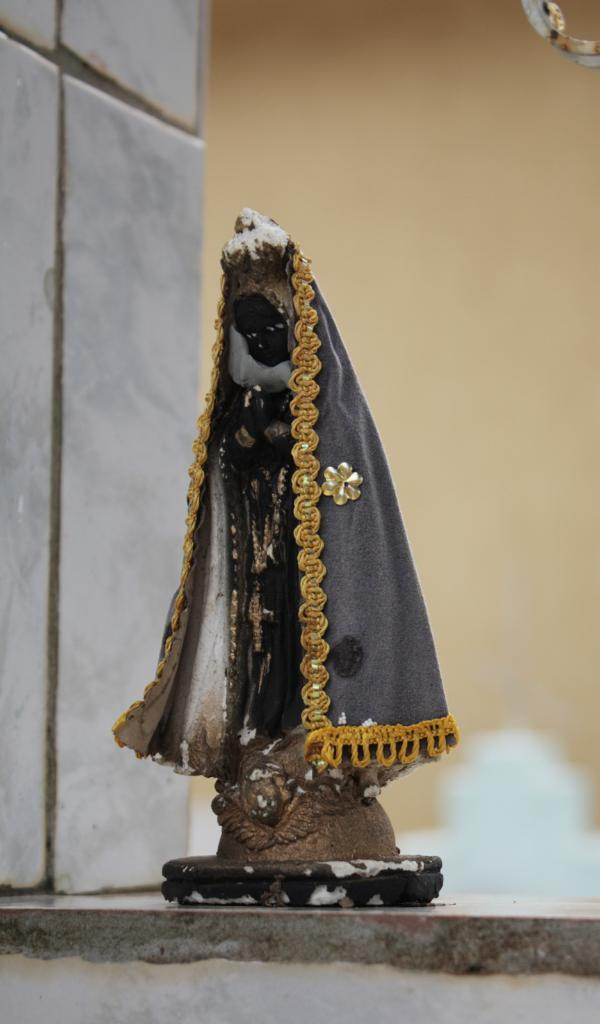What is the main subject in the foreground of the image? There is a toy statue in the foreground of the image. Where is the toy statue placed? The toy statue is on a surface. What can be seen in the background of the image? There is a wall in the background of the image. Can you tell me what type of receipt is attached to the toy statue in the image? There is no receipt present in the image; it only features a toy statue on a surface with a wall in the background. 